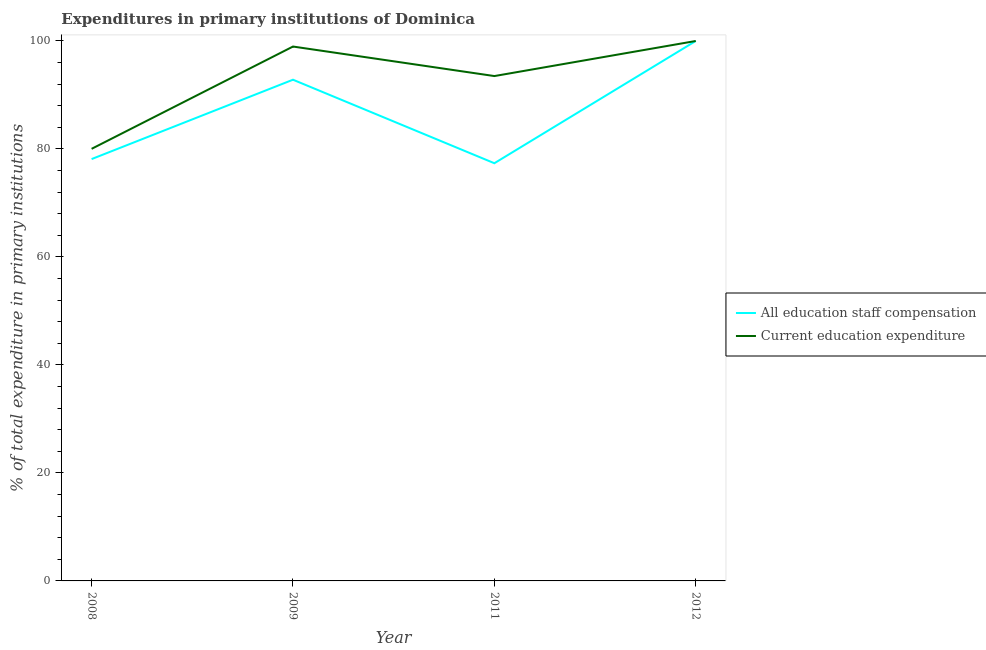How many different coloured lines are there?
Keep it short and to the point. 2. What is the expenditure in education in 2012?
Ensure brevity in your answer.  100. Across all years, what is the maximum expenditure in education?
Offer a terse response. 100. Across all years, what is the minimum expenditure in staff compensation?
Your answer should be compact. 77.36. In which year was the expenditure in staff compensation minimum?
Your response must be concise. 2011. What is the total expenditure in education in the graph?
Your answer should be compact. 372.5. What is the difference between the expenditure in staff compensation in 2009 and that in 2011?
Give a very brief answer. 15.47. What is the difference between the expenditure in education in 2012 and the expenditure in staff compensation in 2008?
Provide a short and direct response. 21.87. What is the average expenditure in staff compensation per year?
Make the answer very short. 87.08. In the year 2008, what is the difference between the expenditure in education and expenditure in staff compensation?
Your answer should be very brief. 1.9. In how many years, is the expenditure in education greater than 88 %?
Your answer should be very brief. 3. What is the ratio of the expenditure in staff compensation in 2008 to that in 2011?
Offer a very short reply. 1.01. Is the expenditure in education in 2009 less than that in 2011?
Keep it short and to the point. No. Is the difference between the expenditure in education in 2008 and 2012 greater than the difference between the expenditure in staff compensation in 2008 and 2012?
Your response must be concise. Yes. What is the difference between the highest and the second highest expenditure in staff compensation?
Make the answer very short. 7.17. What is the difference between the highest and the lowest expenditure in staff compensation?
Make the answer very short. 22.64. Is the sum of the expenditure in staff compensation in 2008 and 2012 greater than the maximum expenditure in education across all years?
Provide a succinct answer. Yes. Is the expenditure in staff compensation strictly greater than the expenditure in education over the years?
Make the answer very short. No. How many lines are there?
Ensure brevity in your answer.  2. How many years are there in the graph?
Provide a succinct answer. 4. Does the graph contain any zero values?
Your answer should be very brief. No. Where does the legend appear in the graph?
Your answer should be compact. Center right. How many legend labels are there?
Ensure brevity in your answer.  2. How are the legend labels stacked?
Make the answer very short. Vertical. What is the title of the graph?
Your answer should be compact. Expenditures in primary institutions of Dominica. Does "Private creditors" appear as one of the legend labels in the graph?
Offer a terse response. No. What is the label or title of the Y-axis?
Your answer should be very brief. % of total expenditure in primary institutions. What is the % of total expenditure in primary institutions of All education staff compensation in 2008?
Make the answer very short. 78.13. What is the % of total expenditure in primary institutions in Current education expenditure in 2008?
Ensure brevity in your answer.  80.03. What is the % of total expenditure in primary institutions in All education staff compensation in 2009?
Provide a succinct answer. 92.83. What is the % of total expenditure in primary institutions of Current education expenditure in 2009?
Ensure brevity in your answer.  98.97. What is the % of total expenditure in primary institutions of All education staff compensation in 2011?
Keep it short and to the point. 77.36. What is the % of total expenditure in primary institutions in Current education expenditure in 2011?
Provide a short and direct response. 93.5. Across all years, what is the minimum % of total expenditure in primary institutions of All education staff compensation?
Your answer should be very brief. 77.36. Across all years, what is the minimum % of total expenditure in primary institutions of Current education expenditure?
Give a very brief answer. 80.03. What is the total % of total expenditure in primary institutions in All education staff compensation in the graph?
Your response must be concise. 348.32. What is the total % of total expenditure in primary institutions of Current education expenditure in the graph?
Provide a succinct answer. 372.5. What is the difference between the % of total expenditure in primary institutions of All education staff compensation in 2008 and that in 2009?
Provide a short and direct response. -14.7. What is the difference between the % of total expenditure in primary institutions in Current education expenditure in 2008 and that in 2009?
Offer a very short reply. -18.94. What is the difference between the % of total expenditure in primary institutions of All education staff compensation in 2008 and that in 2011?
Offer a terse response. 0.77. What is the difference between the % of total expenditure in primary institutions in Current education expenditure in 2008 and that in 2011?
Provide a short and direct response. -13.48. What is the difference between the % of total expenditure in primary institutions of All education staff compensation in 2008 and that in 2012?
Make the answer very short. -21.87. What is the difference between the % of total expenditure in primary institutions in Current education expenditure in 2008 and that in 2012?
Your answer should be compact. -19.97. What is the difference between the % of total expenditure in primary institutions in All education staff compensation in 2009 and that in 2011?
Offer a very short reply. 15.47. What is the difference between the % of total expenditure in primary institutions of Current education expenditure in 2009 and that in 2011?
Offer a terse response. 5.47. What is the difference between the % of total expenditure in primary institutions of All education staff compensation in 2009 and that in 2012?
Ensure brevity in your answer.  -7.17. What is the difference between the % of total expenditure in primary institutions in Current education expenditure in 2009 and that in 2012?
Give a very brief answer. -1.03. What is the difference between the % of total expenditure in primary institutions of All education staff compensation in 2011 and that in 2012?
Ensure brevity in your answer.  -22.64. What is the difference between the % of total expenditure in primary institutions in Current education expenditure in 2011 and that in 2012?
Offer a very short reply. -6.5. What is the difference between the % of total expenditure in primary institutions in All education staff compensation in 2008 and the % of total expenditure in primary institutions in Current education expenditure in 2009?
Provide a succinct answer. -20.84. What is the difference between the % of total expenditure in primary institutions of All education staff compensation in 2008 and the % of total expenditure in primary institutions of Current education expenditure in 2011?
Offer a terse response. -15.38. What is the difference between the % of total expenditure in primary institutions of All education staff compensation in 2008 and the % of total expenditure in primary institutions of Current education expenditure in 2012?
Ensure brevity in your answer.  -21.87. What is the difference between the % of total expenditure in primary institutions in All education staff compensation in 2009 and the % of total expenditure in primary institutions in Current education expenditure in 2011?
Your answer should be very brief. -0.68. What is the difference between the % of total expenditure in primary institutions of All education staff compensation in 2009 and the % of total expenditure in primary institutions of Current education expenditure in 2012?
Offer a very short reply. -7.17. What is the difference between the % of total expenditure in primary institutions in All education staff compensation in 2011 and the % of total expenditure in primary institutions in Current education expenditure in 2012?
Provide a succinct answer. -22.64. What is the average % of total expenditure in primary institutions in All education staff compensation per year?
Offer a terse response. 87.08. What is the average % of total expenditure in primary institutions in Current education expenditure per year?
Give a very brief answer. 93.13. In the year 2009, what is the difference between the % of total expenditure in primary institutions in All education staff compensation and % of total expenditure in primary institutions in Current education expenditure?
Provide a succinct answer. -6.14. In the year 2011, what is the difference between the % of total expenditure in primary institutions in All education staff compensation and % of total expenditure in primary institutions in Current education expenditure?
Your answer should be compact. -16.14. What is the ratio of the % of total expenditure in primary institutions of All education staff compensation in 2008 to that in 2009?
Provide a succinct answer. 0.84. What is the ratio of the % of total expenditure in primary institutions in Current education expenditure in 2008 to that in 2009?
Your answer should be compact. 0.81. What is the ratio of the % of total expenditure in primary institutions of All education staff compensation in 2008 to that in 2011?
Provide a succinct answer. 1.01. What is the ratio of the % of total expenditure in primary institutions in Current education expenditure in 2008 to that in 2011?
Make the answer very short. 0.86. What is the ratio of the % of total expenditure in primary institutions of All education staff compensation in 2008 to that in 2012?
Your answer should be compact. 0.78. What is the ratio of the % of total expenditure in primary institutions in Current education expenditure in 2008 to that in 2012?
Offer a very short reply. 0.8. What is the ratio of the % of total expenditure in primary institutions in All education staff compensation in 2009 to that in 2011?
Your answer should be compact. 1.2. What is the ratio of the % of total expenditure in primary institutions of Current education expenditure in 2009 to that in 2011?
Your response must be concise. 1.06. What is the ratio of the % of total expenditure in primary institutions of All education staff compensation in 2009 to that in 2012?
Provide a short and direct response. 0.93. What is the ratio of the % of total expenditure in primary institutions of All education staff compensation in 2011 to that in 2012?
Give a very brief answer. 0.77. What is the ratio of the % of total expenditure in primary institutions of Current education expenditure in 2011 to that in 2012?
Your answer should be compact. 0.94. What is the difference between the highest and the second highest % of total expenditure in primary institutions in All education staff compensation?
Provide a succinct answer. 7.17. What is the difference between the highest and the second highest % of total expenditure in primary institutions in Current education expenditure?
Your answer should be very brief. 1.03. What is the difference between the highest and the lowest % of total expenditure in primary institutions in All education staff compensation?
Ensure brevity in your answer.  22.64. What is the difference between the highest and the lowest % of total expenditure in primary institutions of Current education expenditure?
Provide a short and direct response. 19.97. 